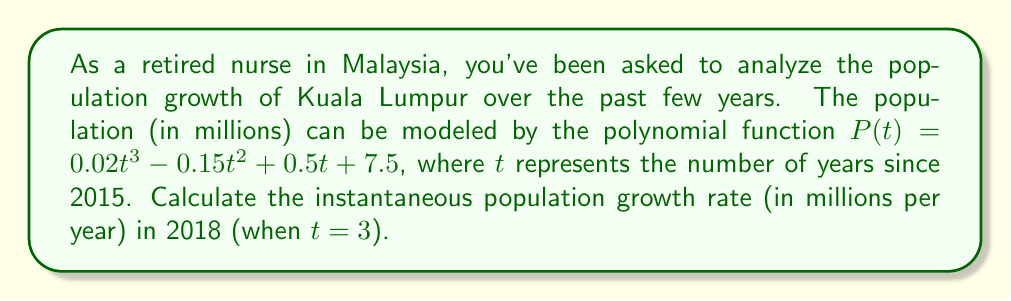Help me with this question. To find the instantaneous population growth rate at a specific point in time, we need to calculate the derivative of the population function $P(t)$ and evaluate it at $t = 3$.

1. Given population function: $P(t) = 0.02t^3 - 0.15t^2 + 0.5t + 7.5$

2. Calculate the derivative $P'(t)$:
   $$P'(t) = \frac{d}{dt}(0.02t^3 - 0.15t^2 + 0.5t + 7.5)$$
   $$P'(t) = 0.06t^2 - 0.3t + 0.5$$

3. Evaluate $P'(t)$ at $t = 3$:
   $$P'(3) = 0.06(3)^2 - 0.3(3) + 0.5$$
   $$P'(3) = 0.06(9) - 0.9 + 0.5$$
   $$P'(3) = 0.54 - 0.9 + 0.5$$
   $$P'(3) = 0.14$$

The instantaneous population growth rate in 2018 (when $t = 3$) is 0.14 million people per year.
Answer: 0.14 million people per year 